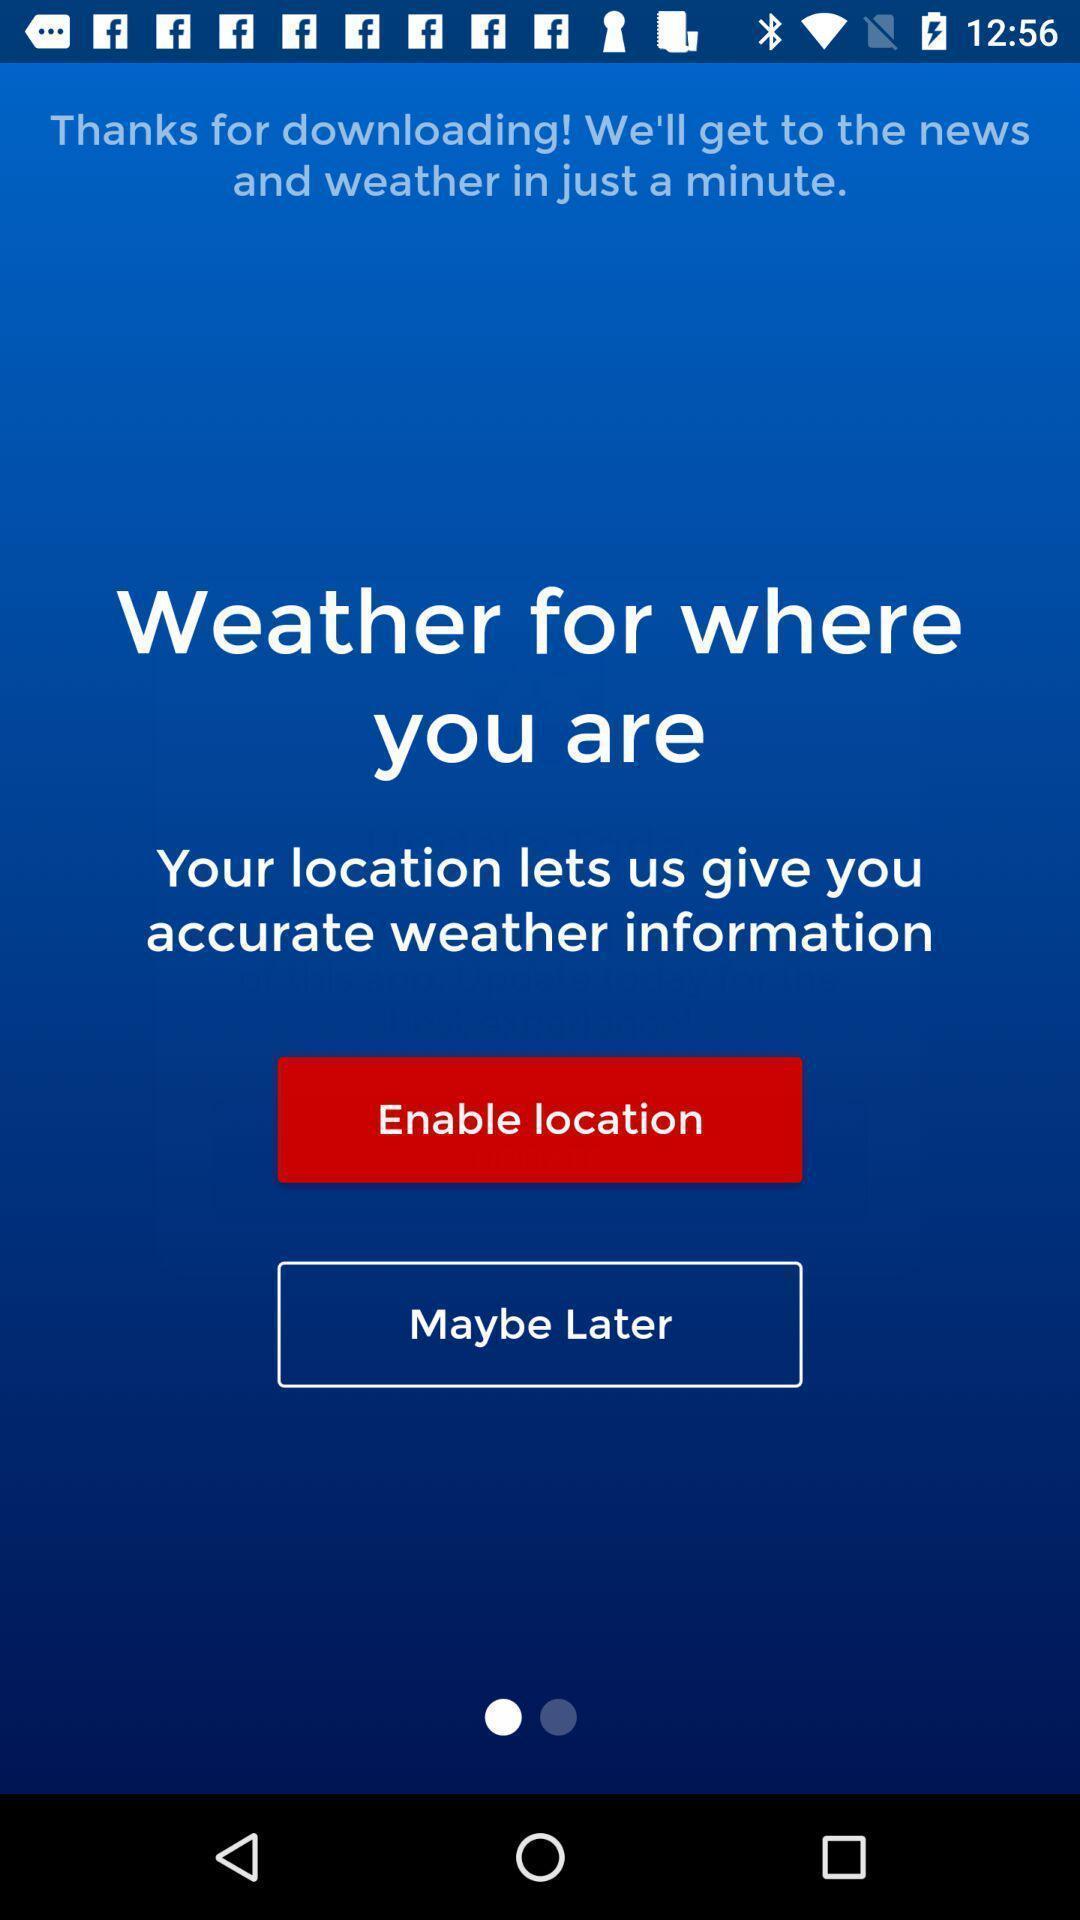Please provide a description for this image. Welcome page. 